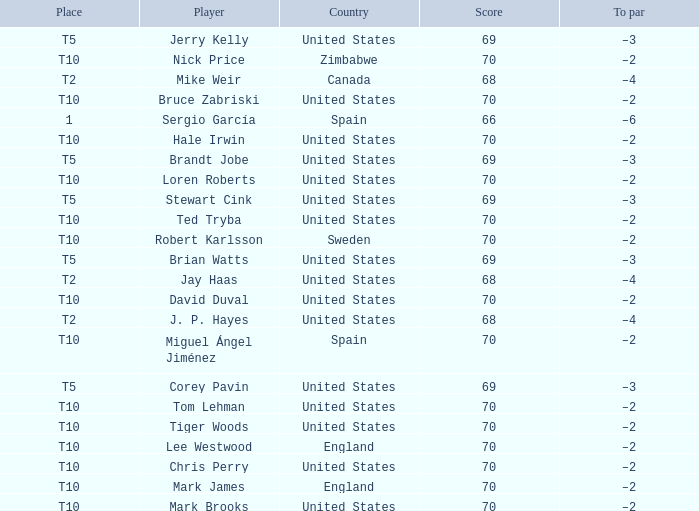I'm looking to parse the entire table for insights. Could you assist me with that? {'header': ['Place', 'Player', 'Country', 'Score', 'To par'], 'rows': [['T5', 'Jerry Kelly', 'United States', '69', '–3'], ['T10', 'Nick Price', 'Zimbabwe', '70', '–2'], ['T2', 'Mike Weir', 'Canada', '68', '–4'], ['T10', 'Bruce Zabriski', 'United States', '70', '–2'], ['1', 'Sergio García', 'Spain', '66', '–6'], ['T10', 'Hale Irwin', 'United States', '70', '–2'], ['T5', 'Brandt Jobe', 'United States', '69', '–3'], ['T10', 'Loren Roberts', 'United States', '70', '–2'], ['T5', 'Stewart Cink', 'United States', '69', '–3'], ['T10', 'Ted Tryba', 'United States', '70', '–2'], ['T10', 'Robert Karlsson', 'Sweden', '70', '–2'], ['T5', 'Brian Watts', 'United States', '69', '–3'], ['T2', 'Jay Haas', 'United States', '68', '–4'], ['T10', 'David Duval', 'United States', '70', '–2'], ['T2', 'J. P. Hayes', 'United States', '68', '–4'], ['T10', 'Miguel Ángel Jiménez', 'Spain', '70', '–2'], ['T5', 'Corey Pavin', 'United States', '69', '–3'], ['T10', 'Tom Lehman', 'United States', '70', '–2'], ['T10', 'Tiger Woods', 'United States', '70', '–2'], ['T10', 'Lee Westwood', 'England', '70', '–2'], ['T10', 'Chris Perry', 'United States', '70', '–2'], ['T10', 'Mark James', 'England', '70', '–2'], ['T10', 'Mark Brooks', 'United States', '70', '–2']]} What was the To par of the golfer that placed t5? –3, –3, –3, –3, –3. 